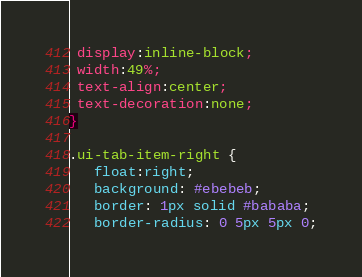Convert code to text. <code><loc_0><loc_0><loc_500><loc_500><_CSS_> display:inline-block;
 width:49%;
 text-align:center;
 text-decoration:none;
}

.ui-tab-item-right {
   float:right;
   background: #ebebeb;
   border: 1px solid #bababa;
   border-radius: 0 5px 5px 0;</code> 